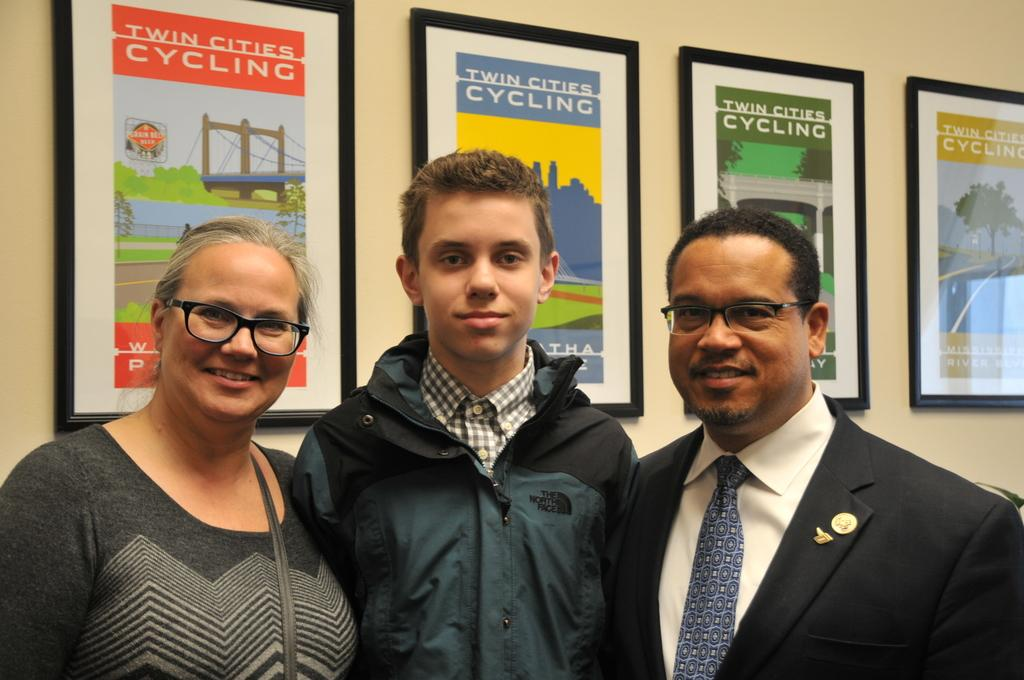How many people are present in the image? There are three persons standing in the middle of the image. What can be seen in the background of the image? There is a wall in the background of the image. What is attached to the wall? There are frames attached to the wall. Where is the woman located in the image? There is a woman on the left side of the image. What type of brush is the woman using to paint the office in the image? There is no brush or office present in the image. The woman is not depicted as painting or in an office setting. 